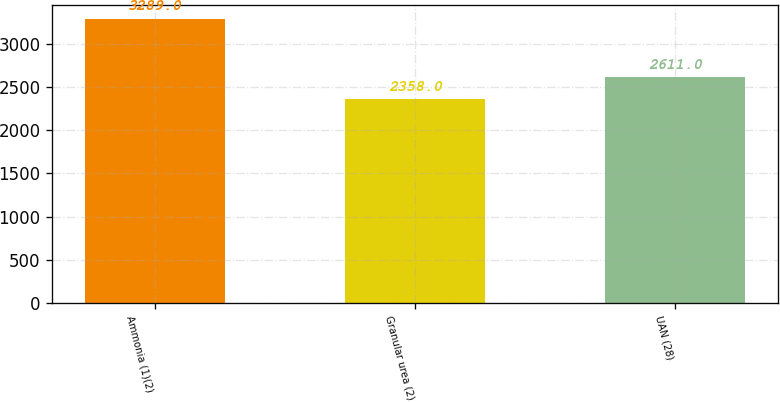<chart> <loc_0><loc_0><loc_500><loc_500><bar_chart><fcel>Ammonia (1)(2)<fcel>Granular urea (2)<fcel>UAN (28)<nl><fcel>3289<fcel>2358<fcel>2611<nl></chart> 